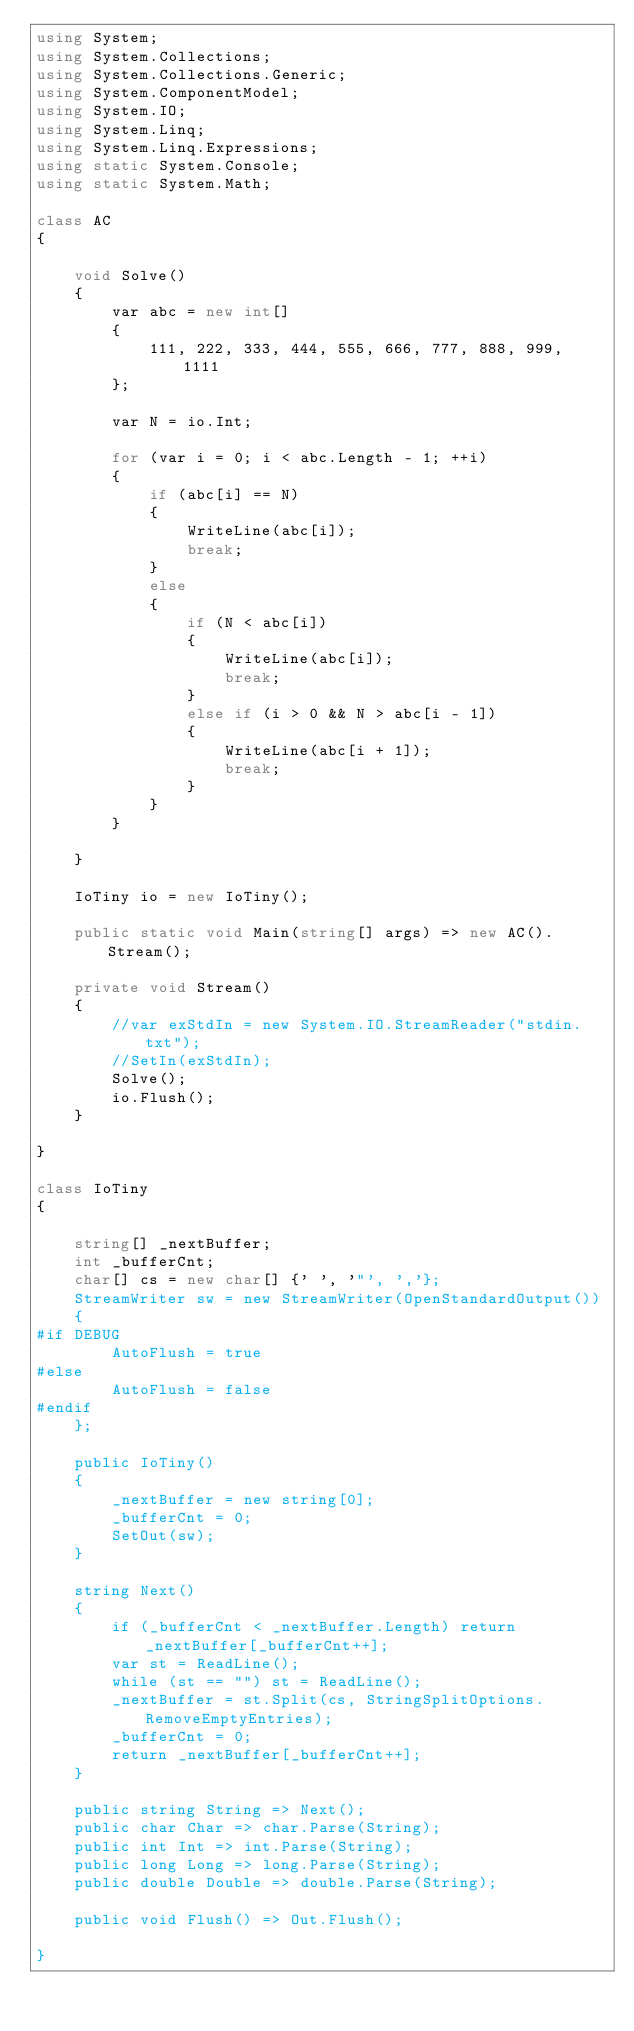<code> <loc_0><loc_0><loc_500><loc_500><_C#_>using System;
using System.Collections;
using System.Collections.Generic;
using System.ComponentModel;
using System.IO;
using System.Linq;
using System.Linq.Expressions;
using static System.Console;
using static System.Math;

class AC
{

    void Solve()
    {
        var abc = new int[]
        {
            111, 222, 333, 444, 555, 666, 777, 888, 999, 1111
        };

        var N = io.Int;

        for (var i = 0; i < abc.Length - 1; ++i)
        {
            if (abc[i] == N)
            {
                WriteLine(abc[i]);
                break;
            }
            else
            {
                if (N < abc[i])
                {
                    WriteLine(abc[i]);
                    break;
                }
                else if (i > 0 && N > abc[i - 1])
                {
                    WriteLine(abc[i + 1]);
                    break;
                }
            }
        }

    }

    IoTiny io = new IoTiny();

    public static void Main(string[] args) => new AC().Stream();

    private void Stream()
    {
        //var exStdIn = new System.IO.StreamReader("stdin.txt");
        //SetIn(exStdIn);
        Solve();
        io.Flush();
    }

}

class IoTiny
{

    string[] _nextBuffer;
    int _bufferCnt;
    char[] cs = new char[] {' ', '"', ','};
    StreamWriter sw = new StreamWriter(OpenStandardOutput())
    {
#if DEBUG
        AutoFlush = true
#else
        AutoFlush = false
#endif
    };

    public IoTiny()
    {
        _nextBuffer = new string[0];
        _bufferCnt = 0;
        SetOut(sw);
    }

    string Next()
    {
        if (_bufferCnt < _nextBuffer.Length) return _nextBuffer[_bufferCnt++];
        var st = ReadLine();
        while (st == "") st = ReadLine();
        _nextBuffer = st.Split(cs, StringSplitOptions.RemoveEmptyEntries);
        _bufferCnt = 0;
        return _nextBuffer[_bufferCnt++];
    }

    public string String => Next();
    public char Char => char.Parse(String);
    public int Int => int.Parse(String);
    public long Long => long.Parse(String);
    public double Double => double.Parse(String);

    public void Flush() => Out.Flush();

}
</code> 